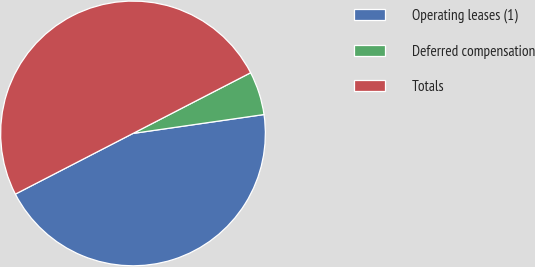<chart> <loc_0><loc_0><loc_500><loc_500><pie_chart><fcel>Operating leases (1)<fcel>Deferred compensation<fcel>Totals<nl><fcel>44.7%<fcel>5.3%<fcel>50.0%<nl></chart> 